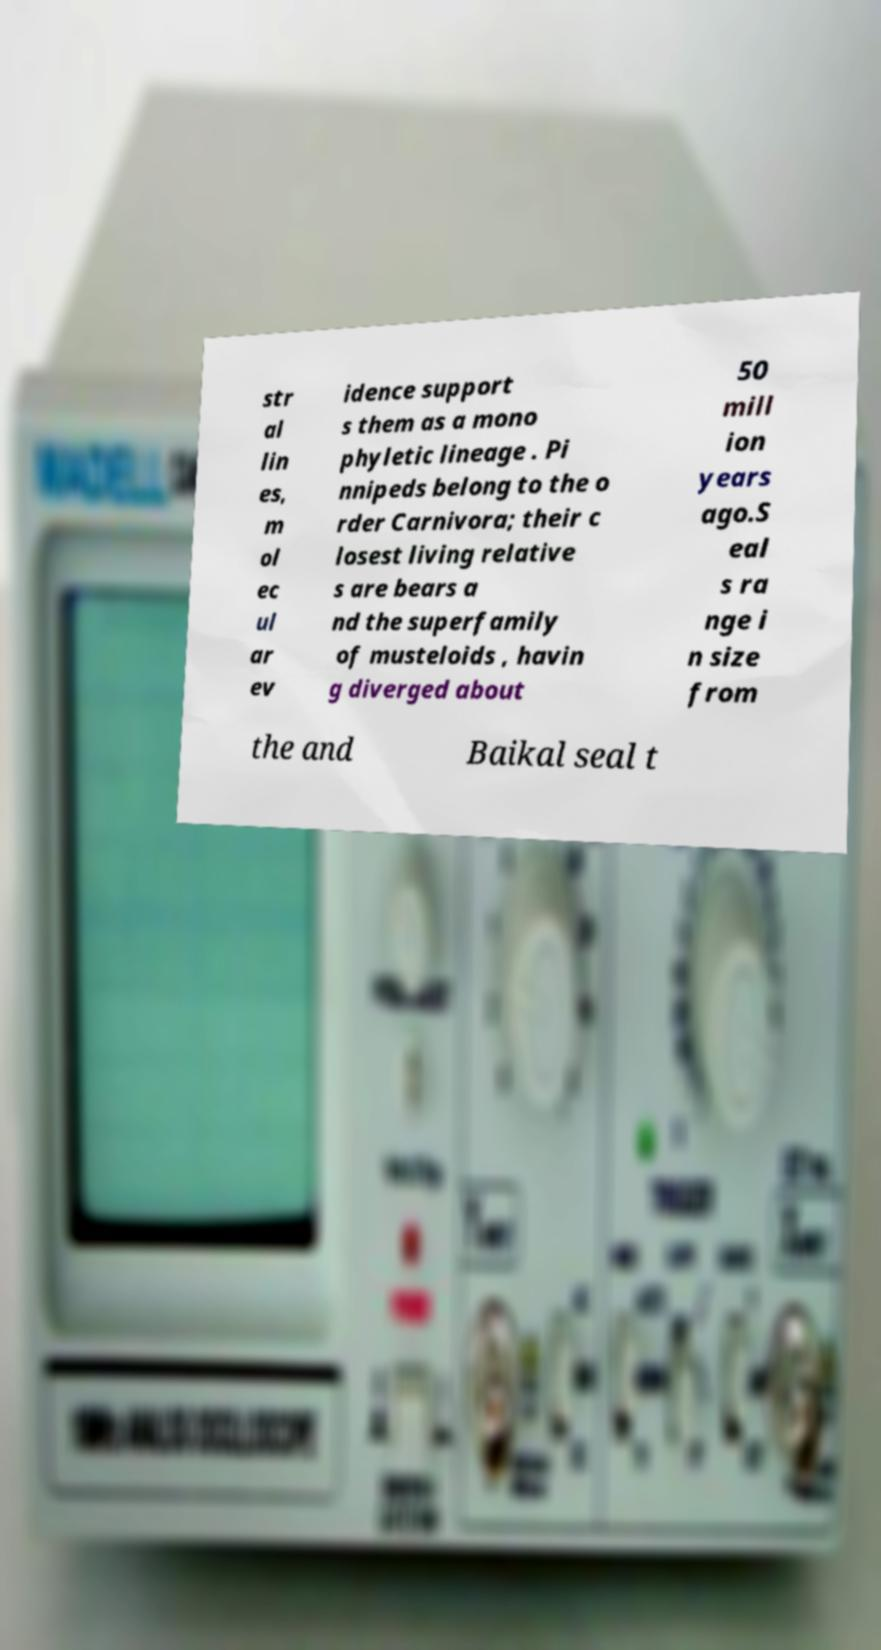I need the written content from this picture converted into text. Can you do that? str al lin es, m ol ec ul ar ev idence support s them as a mono phyletic lineage . Pi nnipeds belong to the o rder Carnivora; their c losest living relative s are bears a nd the superfamily of musteloids , havin g diverged about 50 mill ion years ago.S eal s ra nge i n size from the and Baikal seal t 